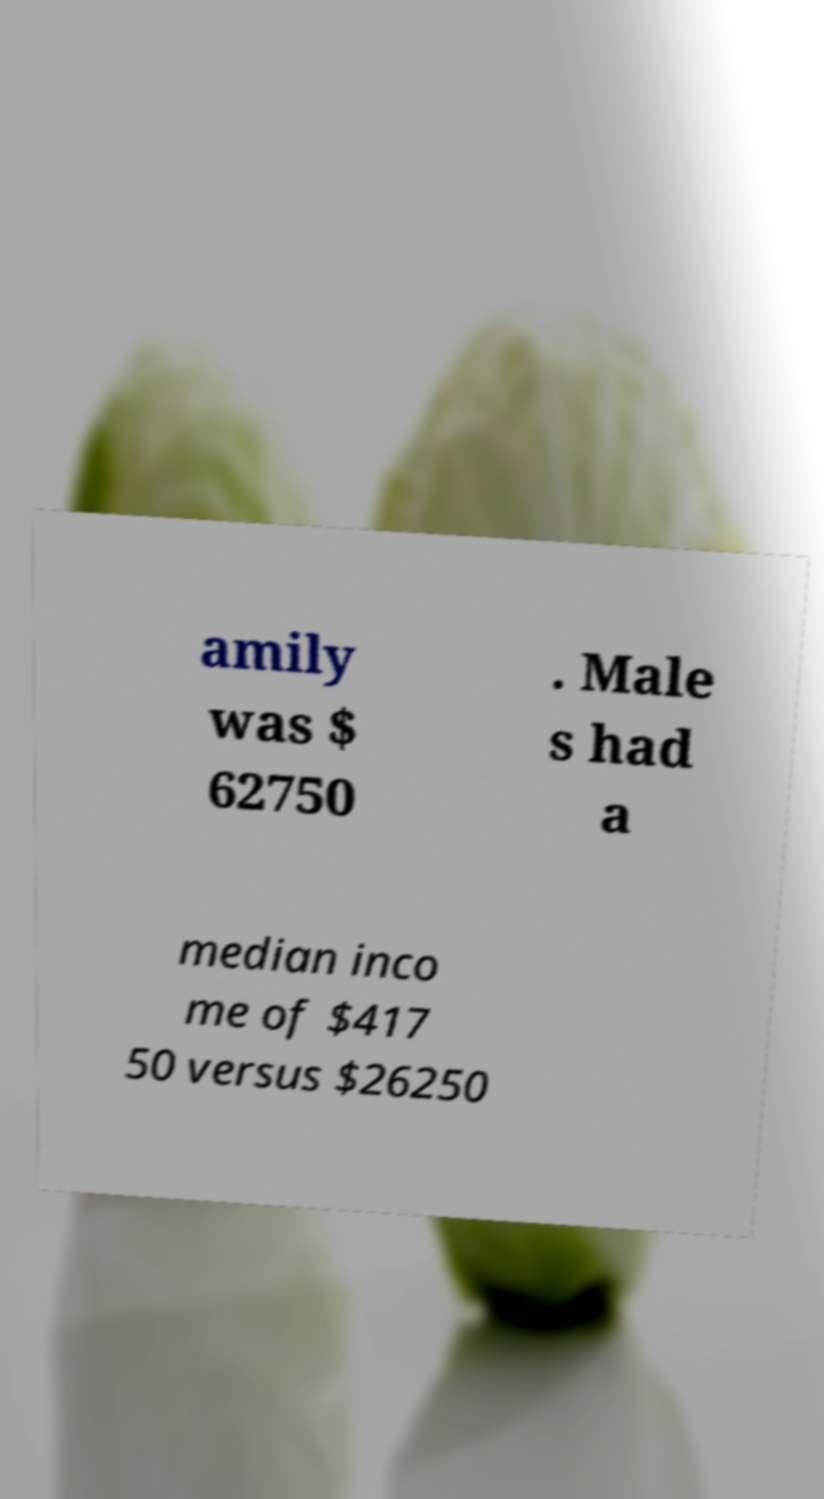Could you extract and type out the text from this image? amily was $ 62750 . Male s had a median inco me of $417 50 versus $26250 